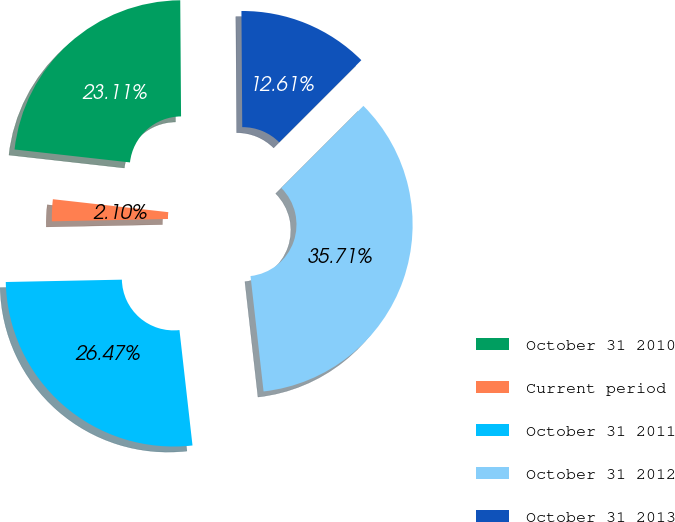Convert chart to OTSL. <chart><loc_0><loc_0><loc_500><loc_500><pie_chart><fcel>October 31 2010<fcel>Current period<fcel>October 31 2011<fcel>October 31 2012<fcel>October 31 2013<nl><fcel>23.11%<fcel>2.1%<fcel>26.47%<fcel>35.71%<fcel>12.61%<nl></chart> 